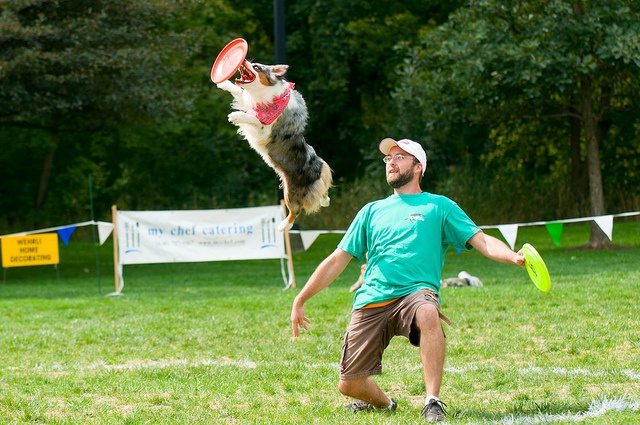Describe the objects in this image and their specific colors. I can see people in gray, ivory, and turquoise tones, dog in gray, lightgray, black, darkgreen, and tan tones, frisbee in gray, pink, lightpink, salmon, and red tones, and frisbee in gray, lime, yellow, and khaki tones in this image. 